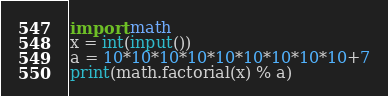Convert code to text. <code><loc_0><loc_0><loc_500><loc_500><_Python_>import math
x = int(input())
a = 10*10*10*10*10*10*10*10*10+7
print(math.factorial(x) % a)</code> 